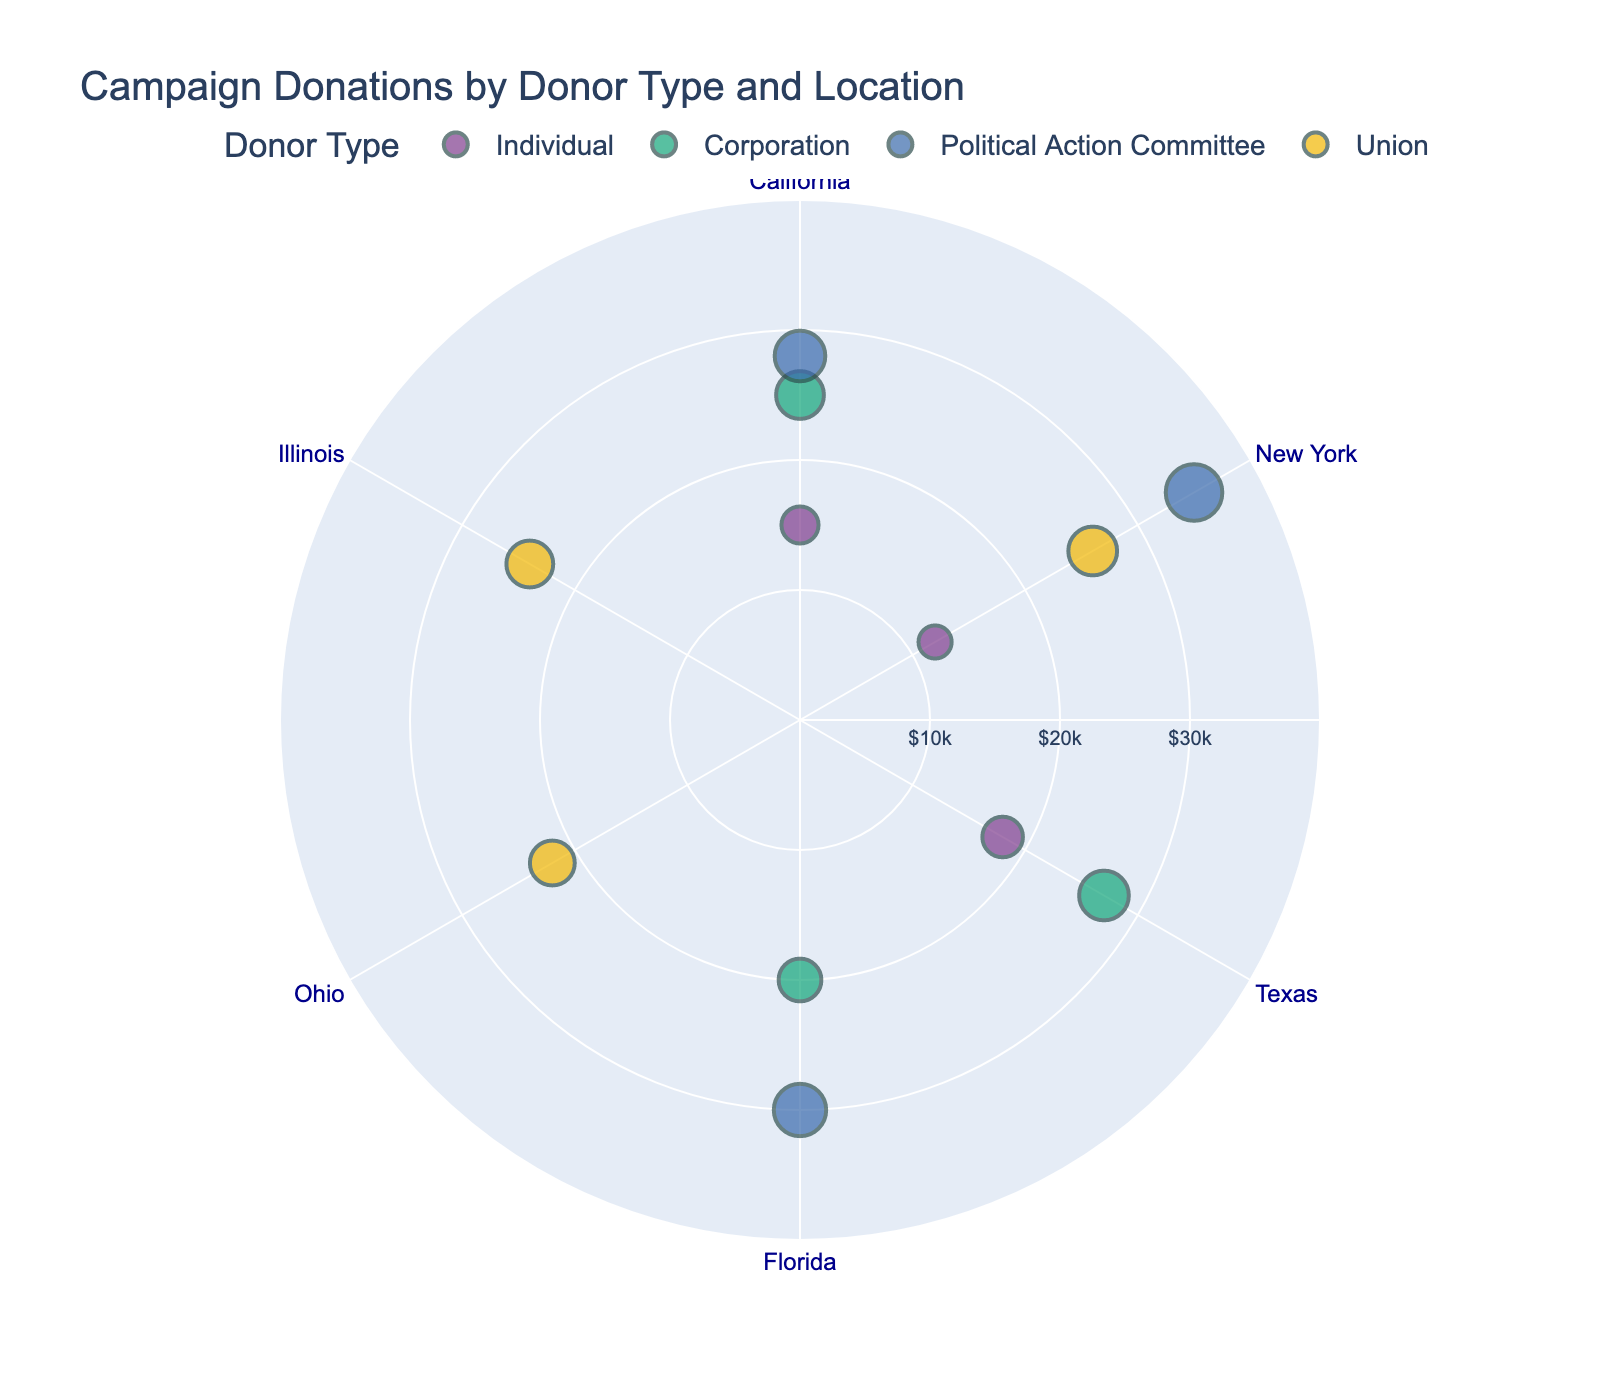What's the title of the figure? The title can be directly observed from the top of the figure.
Answer: Campaign Donations by Donor Type and Location How many geographical locations are represented in the polar scatter plot? Count the different geographical locations shown on the angular axis.
Answer: 6 Which donor type has the highest individual donation amount and where? Check the size and hover information of the largest data point for each donor type, focusing on the Political Action Committee in New York.
Answer: Political Action Committee in New York What is the combined donation amount from Unions across all geographical locations? Sum the donation amounts from Unions in Ohio, Illinois, and New York, which are $22,000, $24,000, and $26,000 respectively: $22,000 + $24,000 + $26,000 = $72,000.
Answer: $72,000 Which geographical location received donations from the most diverse donor types? Identify the location with the highest number of different colored data points.
Answer: California What is the difference in donation amounts between the highest and lowest contributing Political Action Committee in different locations? Identify the donation amounts of Political Action Committees in New York ($35,000) and Florida ($30,000), then calculate the difference: $35,000 - $30,000 = $5,000.
Answer: $5,000 How does the donation amount pattern differ between Corporations and Individuals? Compare the sizes and colors of data points for Corporations and Individuals across the plot. Corporations typically have larger donation amounts compared to Individuals.
Answer: Corporations generally donate more Which geographical locations did not receive any donations from Political Action Committees? Identify locations without data points colored for Political Action Committees.
Answer: Texas, Ohio, Illinois What is the average donation amount from Corporations across the locations they donated to? Sum the donation amounts from Corporations in California ($25,000), Texas ($27,000), and Florida ($20,000), then divide by the number of locations: ($25,000 + $27,000 + $20,000) / 3 = $24,000.
Answer: $24,000 